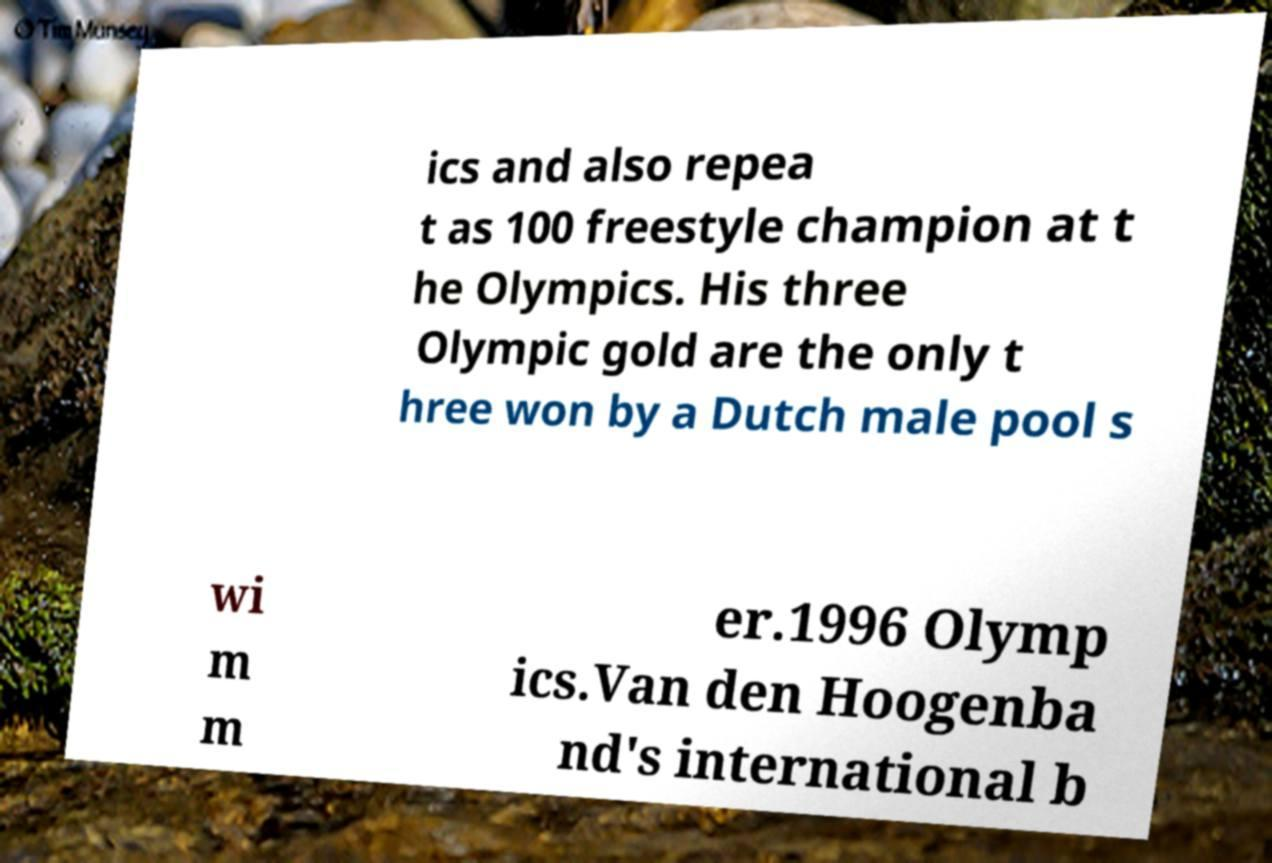I need the written content from this picture converted into text. Can you do that? ics and also repea t as 100 freestyle champion at t he Olympics. His three Olympic gold are the only t hree won by a Dutch male pool s wi m m er.1996 Olymp ics.Van den Hoogenba nd's international b 